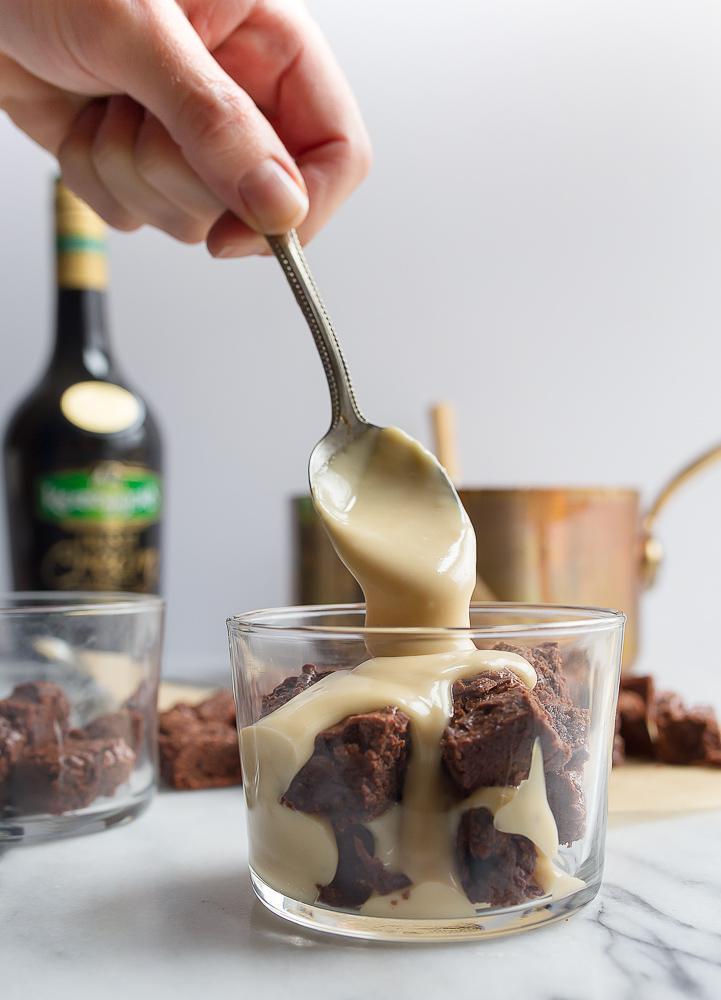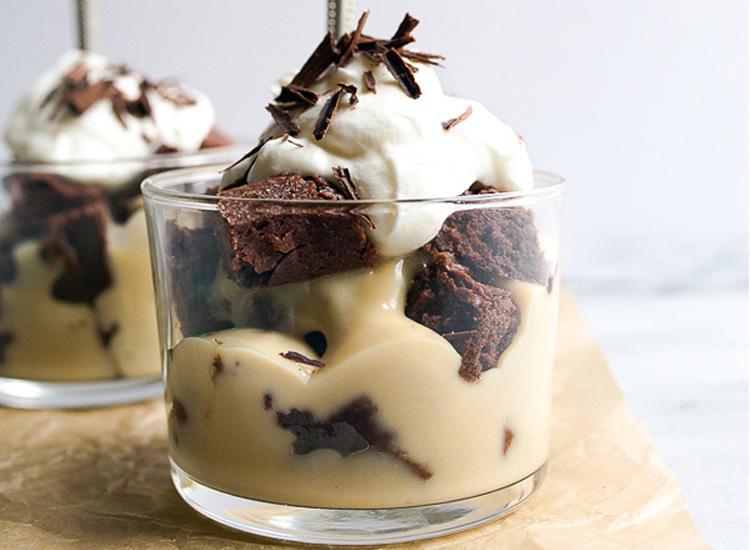The first image is the image on the left, the second image is the image on the right. Assess this claim about the two images: "A bottle of liqueur is visible behind a creamy dessert with brown chunks in it.". Correct or not? Answer yes or no. Yes. The first image is the image on the left, the second image is the image on the right. Evaluate the accuracy of this statement regarding the images: "A bottle of irish cream sits near the desserts in one of the images.". Is it true? Answer yes or no. Yes. 